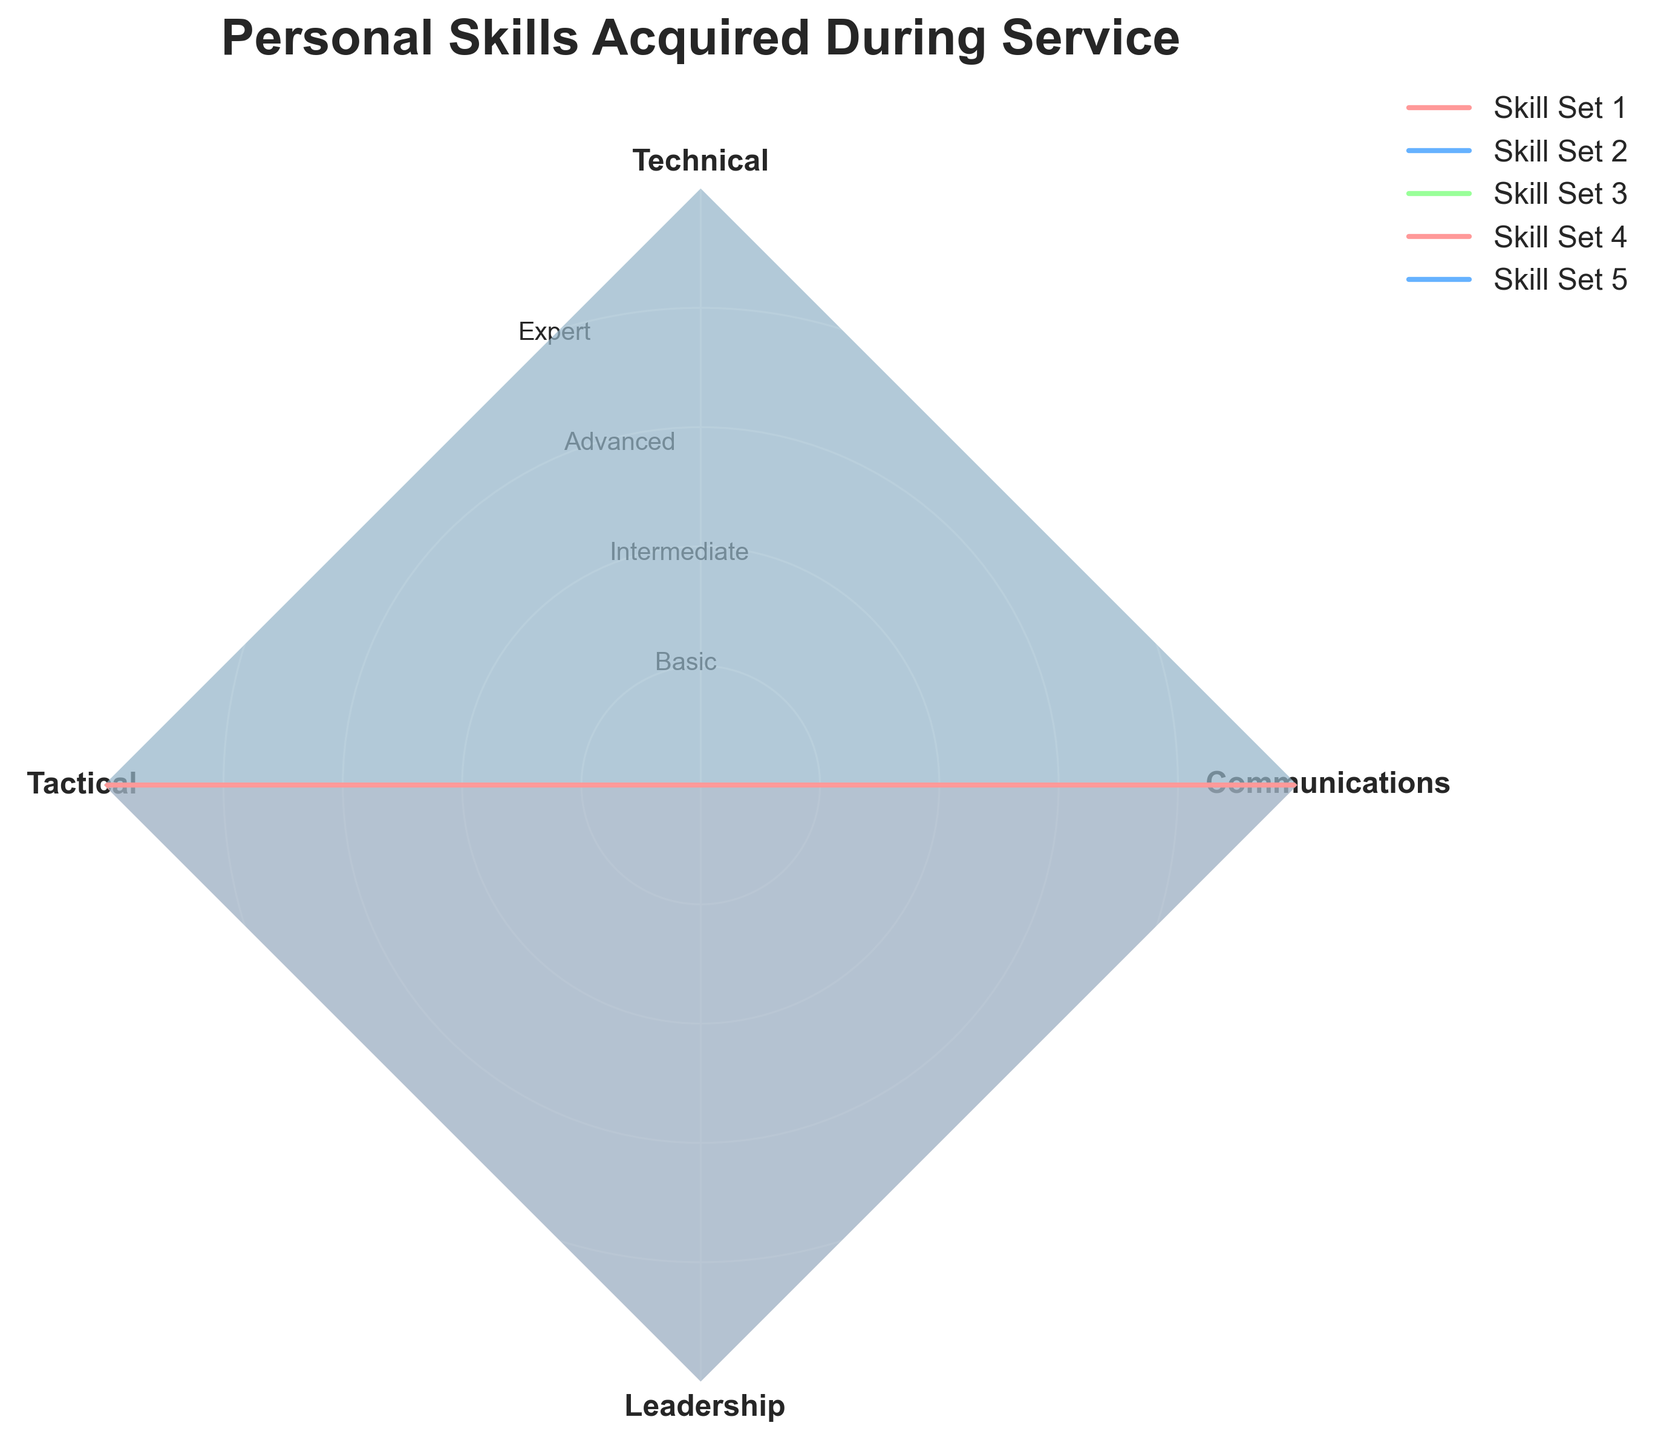What is the title of the radar chart? The title of the radar chart is usually found at the top center of the chart. Here, it should be "Personal Skills Acquired During Service", as indicated in the code generating the figure.
Answer: Personal Skills Acquired During Service How many axes (skills categories) are presented in the radar chart? By looking at the number of labels around the perimeter of the radar chart, you can count that there are four axes/categories: Technical, Tactical, Leadership, and Communications.
Answer: 4 Which color represents Skill Set 1? In the radar chart, Skill Set 1 is represented by the first color in the sequence, which is typically '#FF9999' or a red/pink color as described in the code.
Answer: Red/Pink Which group has the highest value in Communications? To determine the highest value for Communications, visually inspect the chart for the axis labeled "Communications" and note which group's line is farthest from the center along this axis.
Answer: Skill Set 1 Which skill set appears to have the most balanced proficiency across all skills? A balanced proficiency would be indicated by a shape that is fairly circular without extreme peaks or troughs in any direction. Identify the skill set where the plotted line remains even across all axes.
Answer: Skill Set 2 What is the average score for Leadership in Skill Set 3? Check the point on the Leadership axis for Skill Set 3. If the y-values are marked with proficiency levels such as Basic, Intermediate, Advanced, and Expert, find the numerical equivalents of these values, sum them up, and then divide by the number of relevant values.
Answer: Intermediate Which skill set has the lowest value in Technical skills? Look at the Technical axis on the radar chart and compare the plotted values for each skill set, identifying the one with the least distance from the center.
Answer: Skill Set 3 How does the Tactical skill in Skill Set 2 compare to the Technical skill in Skill Set 2? Compare the distance from the center for Tactical and Technical skills within Skill Set 2, noting whether Tactical is greater than, less than, or equal to Technical.
Answer: Tactical is greater than Technical Is the Communication skill level of Skill Set 1 greater than the Leadership skill level of Skill Set 1? Compare the distance from the center on the Communication and Leadership axes for Skill Set 1 to determine which is higher.
Answer: Yes Which skill set has the highest overall proficiency? To find the highest overall proficiency, average the plotted values for each skill set across all axes and identify the highest average.
Answer: Skill Set 1 